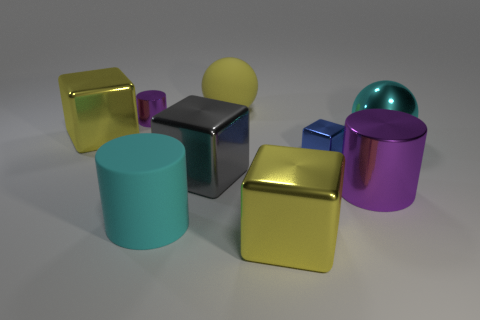Subtract all metallic cylinders. How many cylinders are left? 1 Subtract 2 cylinders. How many cylinders are left? 1 Subtract all purple cubes. How many blue balls are left? 0 Subtract all blue metallic cubes. Subtract all big gray rubber cubes. How many objects are left? 8 Add 4 large metallic balls. How many large metallic balls are left? 5 Add 7 small purple shiny objects. How many small purple shiny objects exist? 8 Add 1 yellow spheres. How many objects exist? 10 Subtract all cyan balls. How many balls are left? 1 Subtract 1 cyan cylinders. How many objects are left? 8 Subtract all balls. How many objects are left? 7 